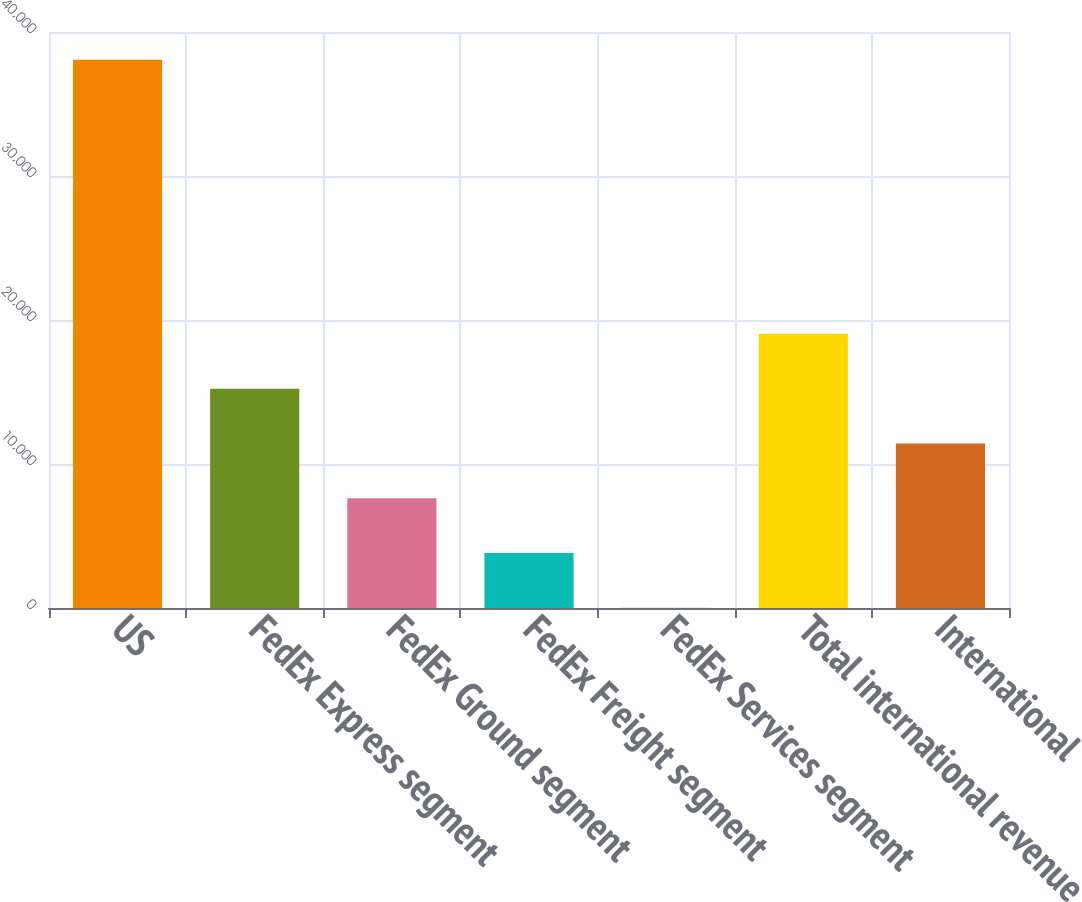Convert chart. <chart><loc_0><loc_0><loc_500><loc_500><bar_chart><fcel>US<fcel>FedEx Express segment<fcel>FedEx Ground segment<fcel>FedEx Freight segment<fcel>FedEx Services segment<fcel>Total international revenue<fcel>International<nl><fcel>38070<fcel>15234<fcel>7622<fcel>3816<fcel>10<fcel>19040<fcel>11428<nl></chart> 